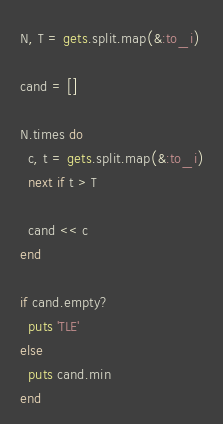<code> <loc_0><loc_0><loc_500><loc_500><_Ruby_>N, T = gets.split.map(&:to_i)

cand = []

N.times do
  c, t = gets.split.map(&:to_i)
  next if t > T

  cand << c
end

if cand.empty?
  puts 'TLE'
else
  puts cand.min
end
</code> 